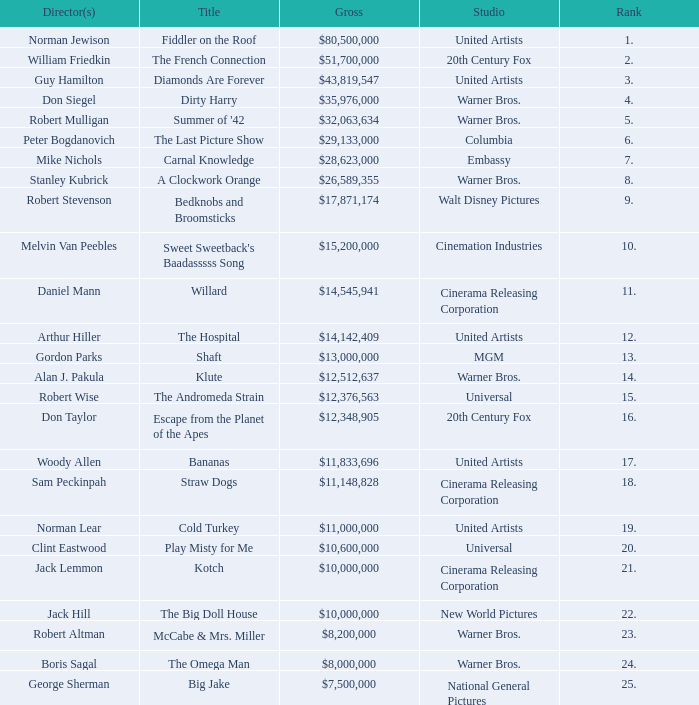What is the rank of The Big Doll House? 22.0. 